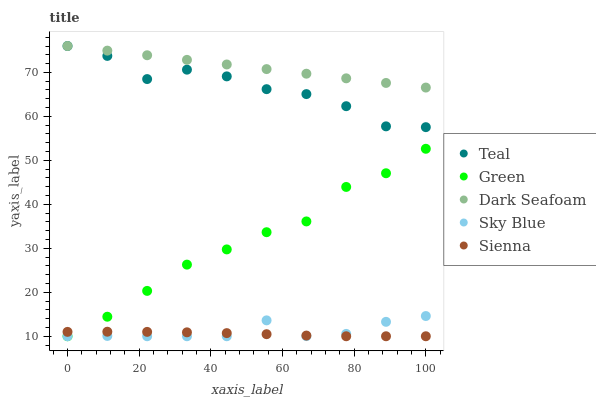Does Sienna have the minimum area under the curve?
Answer yes or no. Yes. Does Dark Seafoam have the maximum area under the curve?
Answer yes or no. Yes. Does Sky Blue have the minimum area under the curve?
Answer yes or no. No. Does Sky Blue have the maximum area under the curve?
Answer yes or no. No. Is Dark Seafoam the smoothest?
Answer yes or no. Yes. Is Teal the roughest?
Answer yes or no. Yes. Is Sky Blue the smoothest?
Answer yes or no. No. Is Sky Blue the roughest?
Answer yes or no. No. Does Sienna have the lowest value?
Answer yes or no. Yes. Does Dark Seafoam have the lowest value?
Answer yes or no. No. Does Teal have the highest value?
Answer yes or no. Yes. Does Sky Blue have the highest value?
Answer yes or no. No. Is Sky Blue less than Teal?
Answer yes or no. Yes. Is Teal greater than Green?
Answer yes or no. Yes. Does Dark Seafoam intersect Teal?
Answer yes or no. Yes. Is Dark Seafoam less than Teal?
Answer yes or no. No. Is Dark Seafoam greater than Teal?
Answer yes or no. No. Does Sky Blue intersect Teal?
Answer yes or no. No. 